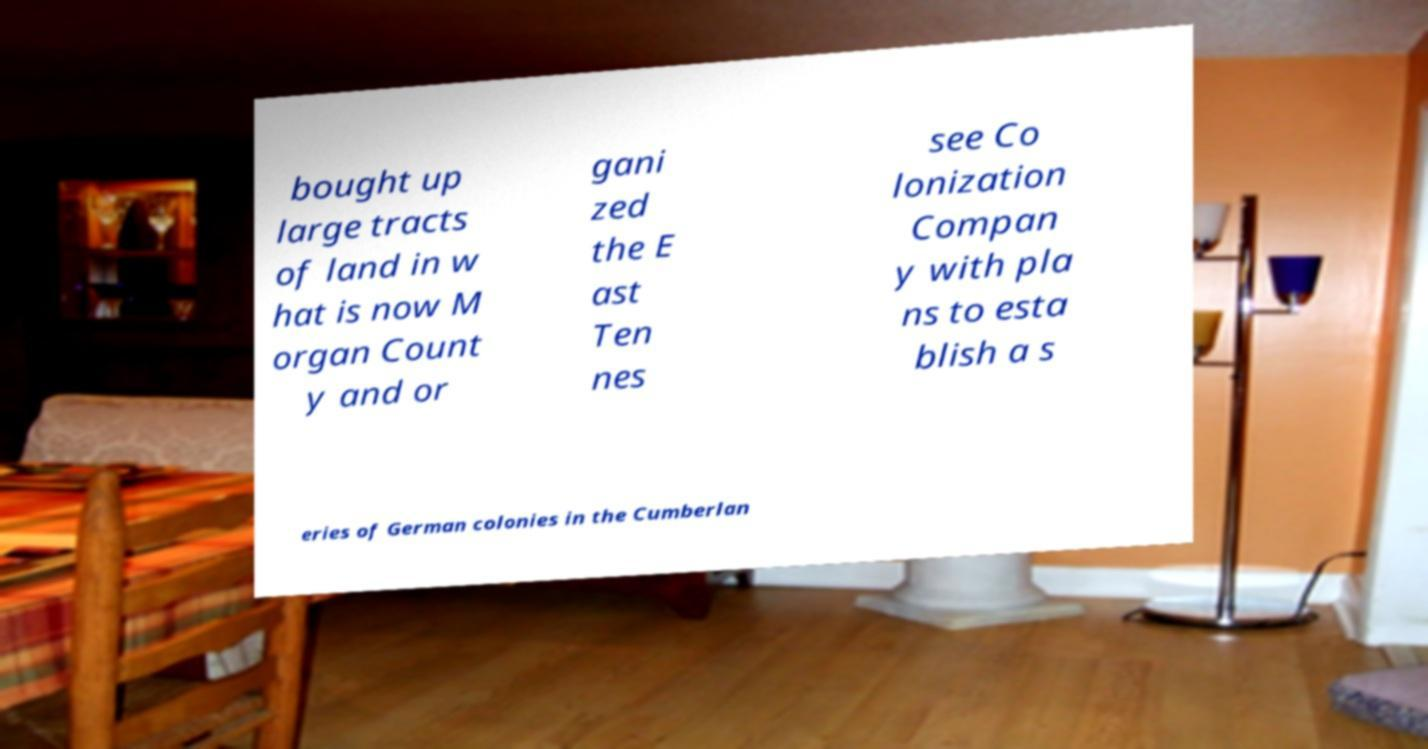Please identify and transcribe the text found in this image. bought up large tracts of land in w hat is now M organ Count y and or gani zed the E ast Ten nes see Co lonization Compan y with pla ns to esta blish a s eries of German colonies in the Cumberlan 